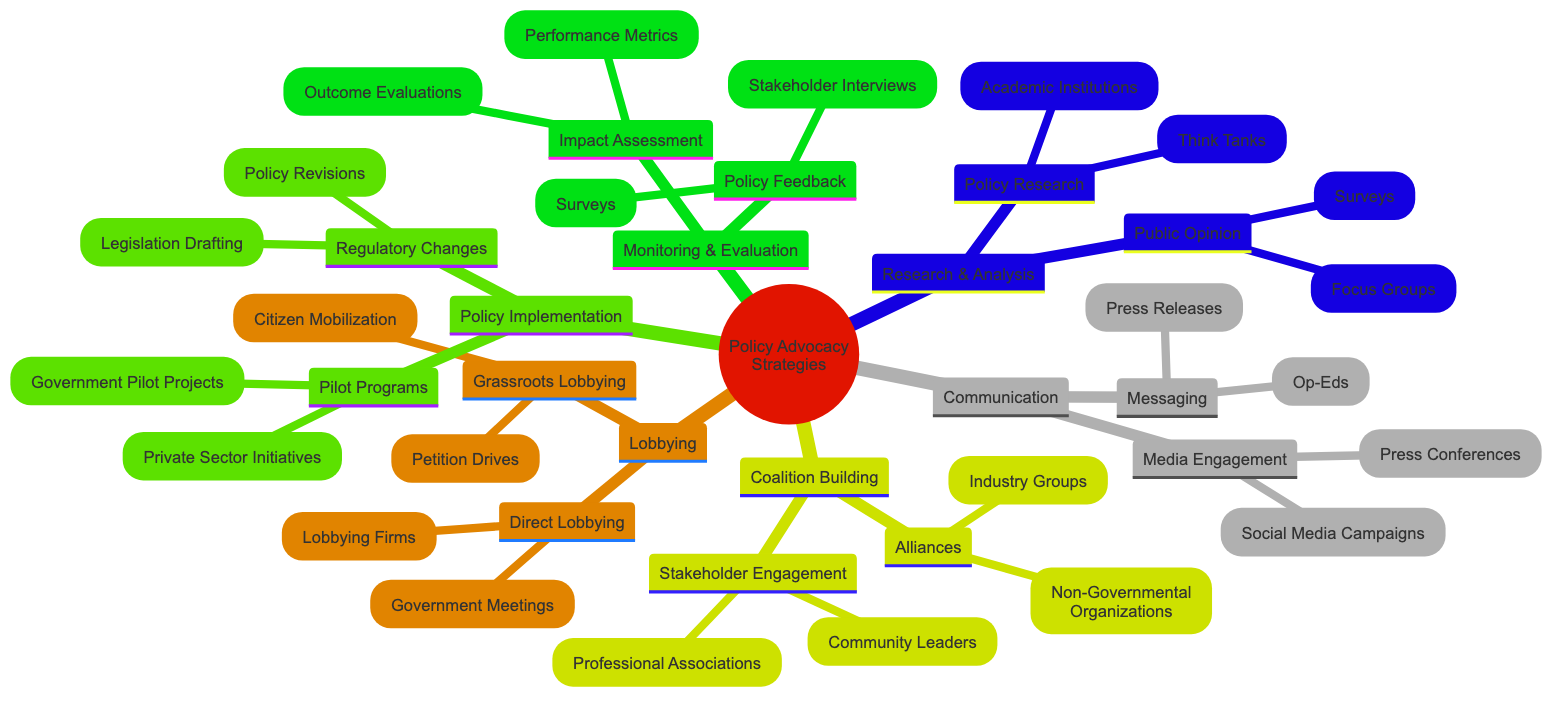What are the two main categories under Policy Implementation? Looking at the Policy Implementation node in the diagram, it branches out into two specific areas: Pilot Programs and Regulatory Changes. These are the primary focuses of this category.
Answer: Pilot Programs, Regulatory Changes Which two tactics fall under Coalition Building? The Coalition Building section has two direct branches: Alliances and Stakeholder Engagement. Each of these contains further strategies, but the question only asks for the primary tactics.
Answer: Alliances, Stakeholder Engagement How many strategies are listed under Communication? In the Communication section, there are two main branches: Messaging and Media Engagement. Each branch contains two tactics, but counting the branches themselves gives a total of two strategies.
Answer: 2 Name one method used for Public Opinion research. Under Public Opinion in the Research and Analysis category, one of the methods listed is Surveys. This is a direct tactic used for gathering public viewpoints.
Answer: Surveys What is the relationship between Direct Lobbying and Grassroots Lobbying? Direct Lobbying and Grassroots Lobbying are both subcategories under the main Lobbying category. They represent different approaches to lobbying, with Direct Lobbying being focused on formal and direct interactions, while Grassroots Lobbying seeks to engage the public.
Answer: Both are subcategories of Lobbying Which group is listed under Alliances? Within the Alliances node in Coalition Building, one of the specified groups is Non-Governmental Organizations. This identifies an organizational type that plays a role in coalition strategies.
Answer: Non-Governmental Organizations What type of evaluation is part of Monitoring and Evaluation? In the Monitoring and Evaluation section, Impact Assessment is a major tactic. This includes evaluating the outcomes and performance metrics, indicating what part of this process aims at measuring results.
Answer: Impact Assessment How many types of feedback methods are included in Policy Feedback? The Policy Feedback section lists two methods: Stakeholder Interviews and Surveys. This means there are two distinct approaches within this category for gathering feedback.
Answer: 2 